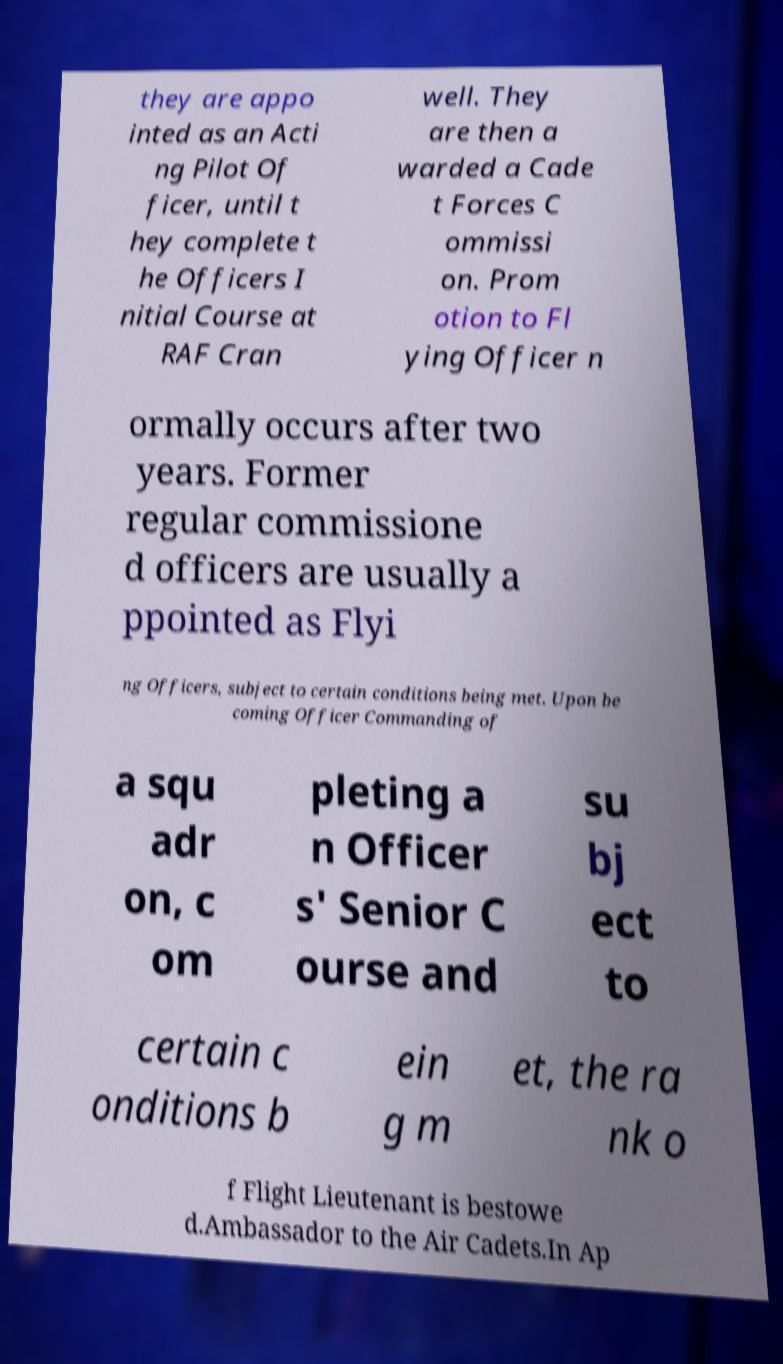For documentation purposes, I need the text within this image transcribed. Could you provide that? they are appo inted as an Acti ng Pilot Of ficer, until t hey complete t he Officers I nitial Course at RAF Cran well. They are then a warded a Cade t Forces C ommissi on. Prom otion to Fl ying Officer n ormally occurs after two years. Former regular commissione d officers are usually a ppointed as Flyi ng Officers, subject to certain conditions being met. Upon be coming Officer Commanding of a squ adr on, c om pleting a n Officer s' Senior C ourse and su bj ect to certain c onditions b ein g m et, the ra nk o f Flight Lieutenant is bestowe d.Ambassador to the Air Cadets.In Ap 